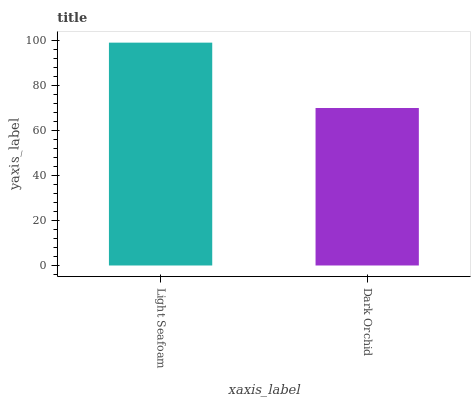Is Dark Orchid the minimum?
Answer yes or no. Yes. Is Light Seafoam the maximum?
Answer yes or no. Yes. Is Dark Orchid the maximum?
Answer yes or no. No. Is Light Seafoam greater than Dark Orchid?
Answer yes or no. Yes. Is Dark Orchid less than Light Seafoam?
Answer yes or no. Yes. Is Dark Orchid greater than Light Seafoam?
Answer yes or no. No. Is Light Seafoam less than Dark Orchid?
Answer yes or no. No. Is Light Seafoam the high median?
Answer yes or no. Yes. Is Dark Orchid the low median?
Answer yes or no. Yes. Is Dark Orchid the high median?
Answer yes or no. No. Is Light Seafoam the low median?
Answer yes or no. No. 